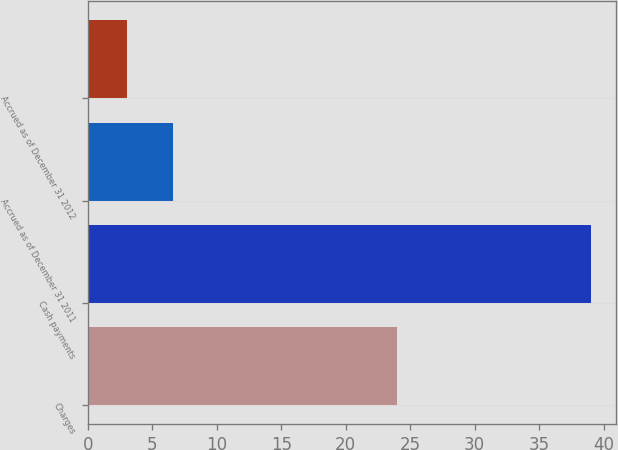Convert chart. <chart><loc_0><loc_0><loc_500><loc_500><bar_chart><fcel>Charges<fcel>Cash payments<fcel>Accrued as of December 31 2011<fcel>Accrued as of December 31 2012<nl><fcel>24<fcel>39<fcel>6.6<fcel>3<nl></chart> 